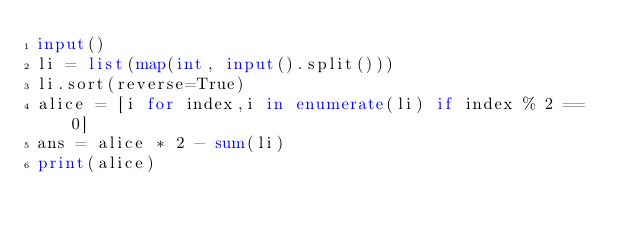<code> <loc_0><loc_0><loc_500><loc_500><_Python_>input()
li = list(map(int, input().split()))
li.sort(reverse=True)
alice = [i for index,i in enumerate(li) if index % 2 == 0]
ans = alice * 2 - sum(li)
print(alice)</code> 